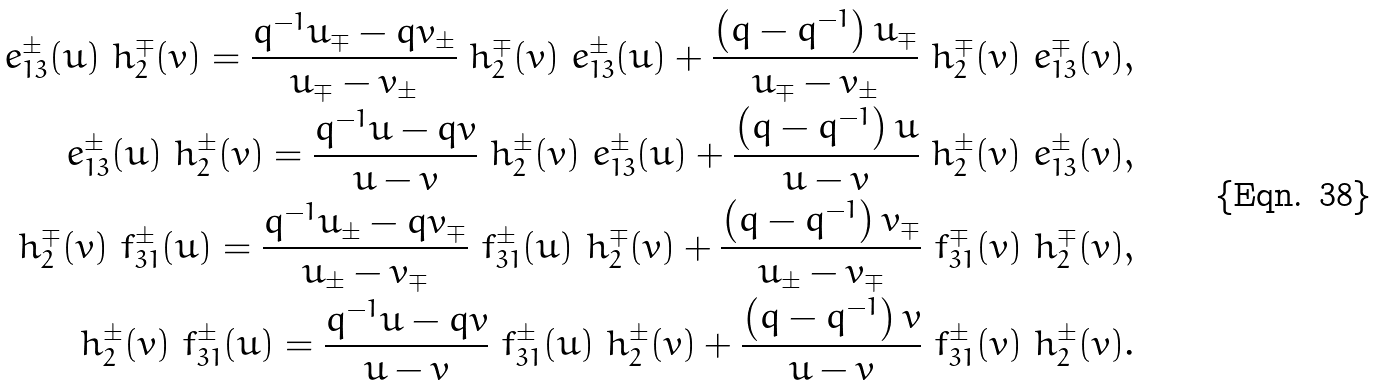<formula> <loc_0><loc_0><loc_500><loc_500>\ e _ { 1 3 } ^ { \pm } ( u ) \ h _ { 2 } ^ { \mp } ( v ) = \frac { q ^ { - 1 } u _ { \mp } - q v _ { \pm } } { u _ { \mp } - v _ { \pm } } \ h _ { 2 } ^ { \mp } ( v ) \ e _ { 1 3 } ^ { \pm } ( u ) + \frac { \left ( q - q ^ { - 1 } \right ) u _ { \mp } } { u _ { \mp } - v _ { \pm } } \ h _ { 2 } ^ { \mp } ( v ) \ e _ { 1 3 } ^ { \mp } ( v ) , \\ \ e _ { 1 3 } ^ { \pm } ( u ) \ h _ { 2 } ^ { \pm } ( v ) = \frac { q ^ { - 1 } u - q v } { u - v } \ h _ { 2 } ^ { \pm } ( v ) \ e _ { 1 3 } ^ { \pm } ( u ) + \frac { \left ( q - q ^ { - 1 } \right ) u } { u - v } \ h _ { 2 } ^ { \pm } ( v ) \ e _ { 1 3 } ^ { \pm } ( v ) , \\ \ h _ { 2 } ^ { \mp } ( v ) \ f _ { 3 1 } ^ { \pm } ( u ) = \frac { q ^ { - 1 } u _ { \pm } - q v _ { \mp } } { u _ { \pm } - v _ { \mp } } \ f _ { 3 1 } ^ { \pm } ( u ) \ h _ { 2 } ^ { \mp } ( v ) + \frac { \left ( q - q ^ { - 1 } \right ) v _ { \mp } } { u _ { \pm } - v _ { \mp } } \ f _ { 3 1 } ^ { \mp } ( v ) \ h _ { 2 } ^ { \mp } ( v ) , \\ \ h _ { 2 } ^ { \pm } ( v ) \ f _ { 3 1 } ^ { \pm } ( u ) = \frac { q ^ { - 1 } u - q v } { u - v } \ f _ { 3 1 } ^ { \pm } ( u ) \ h _ { 2 } ^ { \pm } ( v ) + \frac { \left ( q - q ^ { - 1 } \right ) v } { u - v } \ f _ { 3 1 } ^ { \pm } ( v ) \ h _ { 2 } ^ { \pm } ( v ) .</formula> 